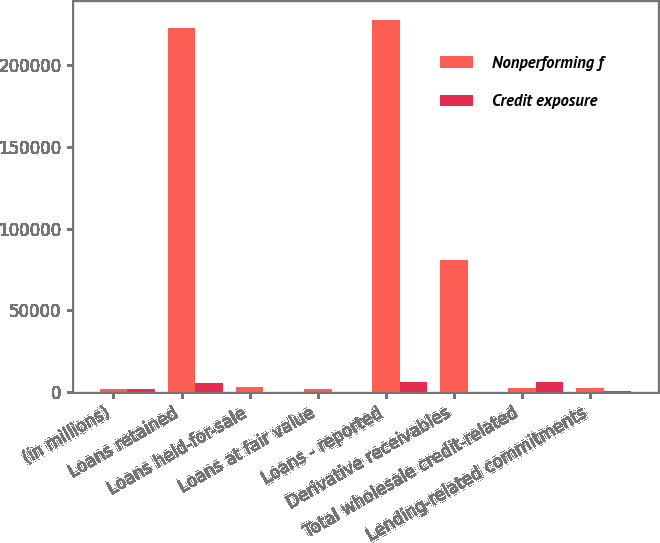<chart> <loc_0><loc_0><loc_500><loc_500><stacked_bar_chart><ecel><fcel>(in millions)<fcel>Loans retained<fcel>Loans held-for-sale<fcel>Loans at fair value<fcel>Loans - reported<fcel>Derivative receivables<fcel>Total wholesale credit-related<fcel>Lending-related commitments<nl><fcel>Nonperforming f<fcel>2010<fcel>222510<fcel>3147<fcel>1976<fcel>227633<fcel>80481<fcel>2578.5<fcel>2578.5<nl><fcel>Credit exposure<fcel>2010<fcel>5510<fcel>341<fcel>155<fcel>6006<fcel>34<fcel>6040<fcel>1005<nl></chart> 